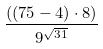Convert formula to latex. <formula><loc_0><loc_0><loc_500><loc_500>\frac { ( ( 7 5 - 4 ) \cdot 8 ) } { 9 ^ { \sqrt { 3 1 } } }</formula> 